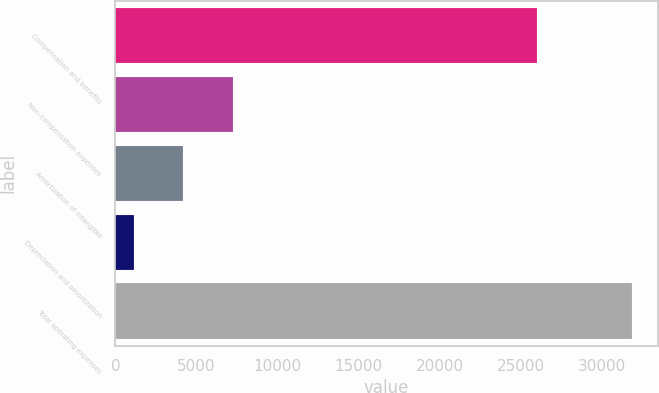Convert chart to OTSL. <chart><loc_0><loc_0><loc_500><loc_500><bar_chart><fcel>Compensation and benefits<fcel>Non-compensation expenses<fcel>Amortization of intangible<fcel>Depreciation and amortization<fcel>Total operating expenses<nl><fcel>25985<fcel>7263.4<fcel>4191.7<fcel>1120<fcel>31837<nl></chart> 